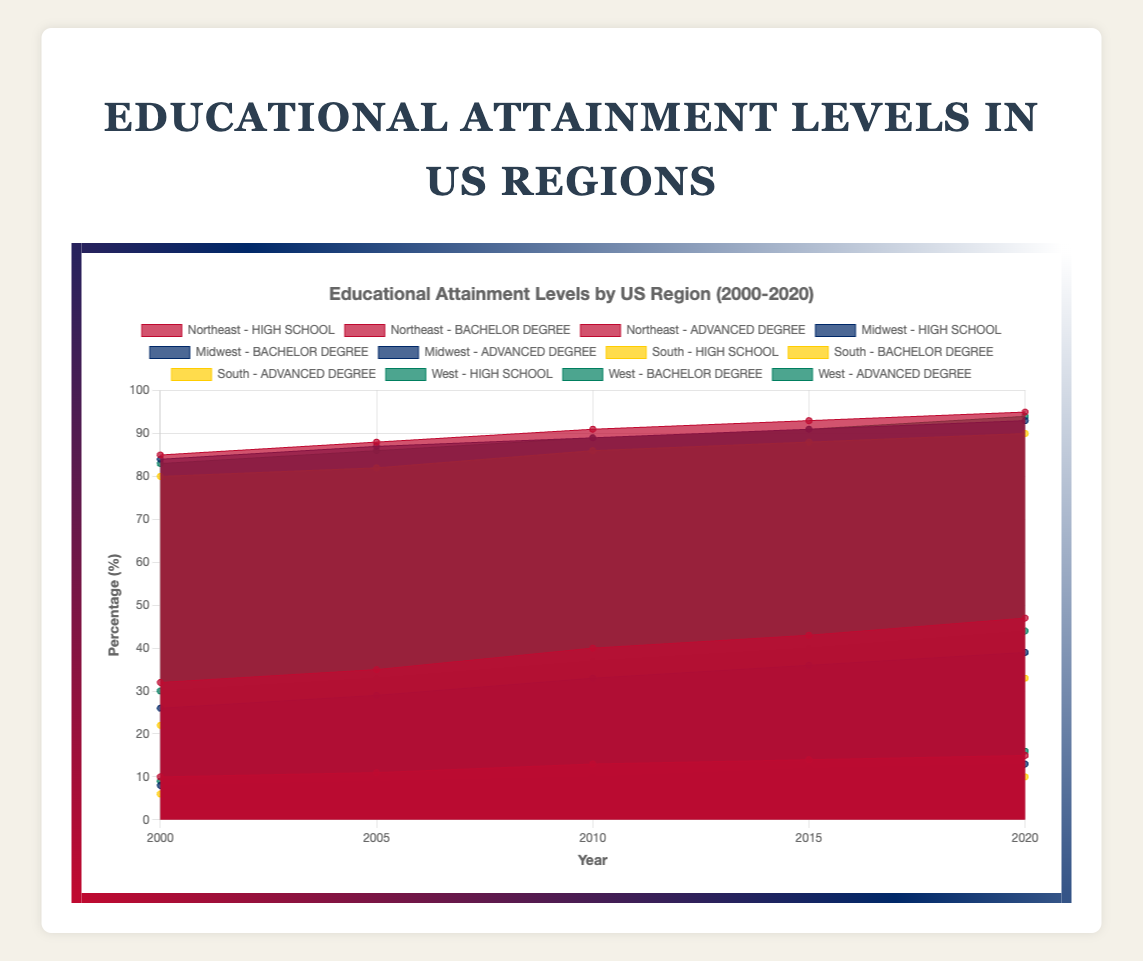what are the educational attainment levels represented in the chart? The chart shows three educational attainment levels: high school completion, bachelor's degree, and advanced degree. These levels are differentiated by region and plotted over time.
Answer: high school, bachelor's degree, advanced degree Which region had the highest percentage of high school completion in 2020? Observing the chart, the highest percentage for high school completion in 2020 is shown in the Northeast region with 95%.
Answer: Northeast How has the percentage of bachelor's degree holders in the South changed from 2000 to 2020? In the South, bachelor's degree holders increased from 22% in 2000 to 33% in 2020. This is determined by reading the values off the chart for the specified years.
Answer: Increased from 22% to 33% Which region had the highest increase in bachelor's degree holders from 2000 to 2020? By comparing the initial and final values for bachelor's degree attainment in each region, the Northeast had the highest increase from 32% to 47%, indicating a 15% rise.
Answer: Northeast What percentage of the Midwest population held an advanced degree in 2015? The percentage of the Midwest population with an advanced degree in 2015 can be seen in the chart as 12%.
Answer: 12% Between which years did the Northeast see the largest increase in high school completion percentages? Observing the changes between each data point, the largest increase for the Northeast high school completion occurred between 2005 and 2010, rising from 88% to 91%.
Answer: 2005 to 2010 Compare the 2020 percentages of advanced degree holders in the Midwest and the West. In 2020, the chart shows 13% of the Midwest population holds advanced degrees, while the West has 16%. Therefore, the West has a higher percentage by 3%.
Answer: West What is the overall trend for high school completion in all regions from 2000 to 2020? The overall trend for high school completion across all regions is increasing. Each region shows a steady rise in high school completion percentages over time.
Answer: Increasing Calculate the average percentage of bachelor's degree holders in the West across all years shown. Adding percentages from all years for the West (30, 33, 37, 40, 44) and dividing by the number of years (5) gives (30+33+37+40+44)/5 = 36.8%.
Answer: 36.8% Which region showed the smallest growth in advanced degrees from 2000 to 2020? Comparing the growth in advanced degrees, the South showed the smallest increase, starting at 6% in 2000 and ending at 10% in 2020, marking a 4% growth.
Answer: South 